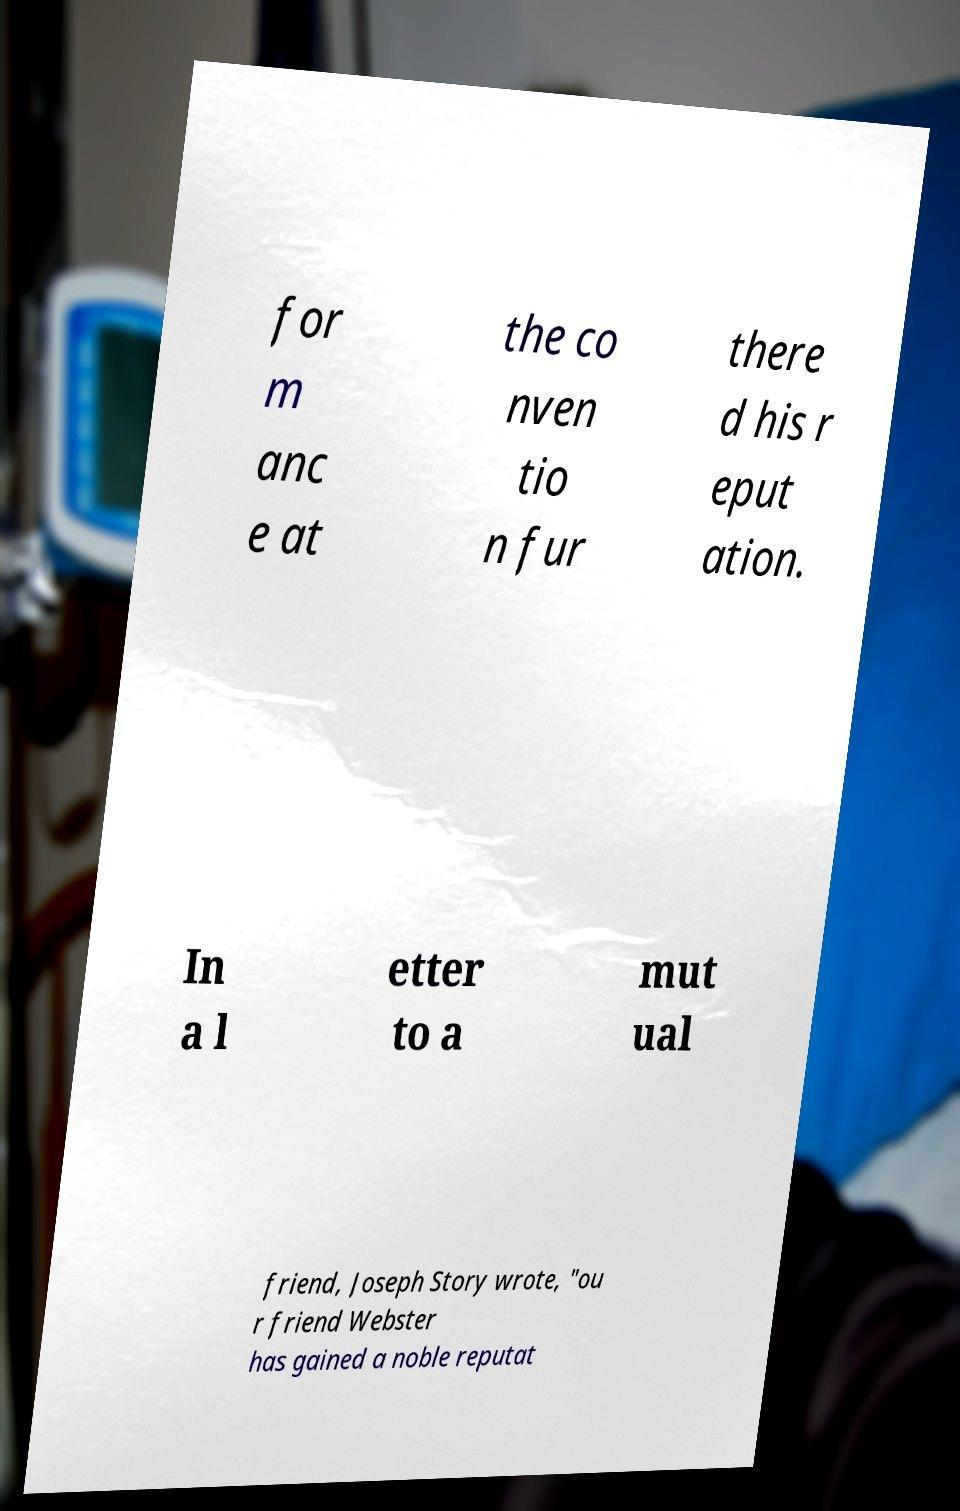What messages or text are displayed in this image? I need them in a readable, typed format. for m anc e at the co nven tio n fur there d his r eput ation. In a l etter to a mut ual friend, Joseph Story wrote, "ou r friend Webster has gained a noble reputat 